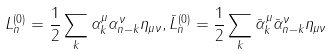<formula> <loc_0><loc_0><loc_500><loc_500>L _ { n } ^ { ( 0 ) } = \frac { 1 } { 2 } \sum _ { k } \alpha _ { k } ^ { \mu } \alpha _ { n - k } ^ { \nu } \eta _ { \mu \nu } , \bar { L } _ { n } ^ { ( 0 ) } = \frac { 1 } { 2 } \sum _ { k } \bar { \alpha } _ { k } ^ { \mu } \bar { \alpha } _ { n - k } ^ { \nu } \eta _ { \mu \nu }</formula> 